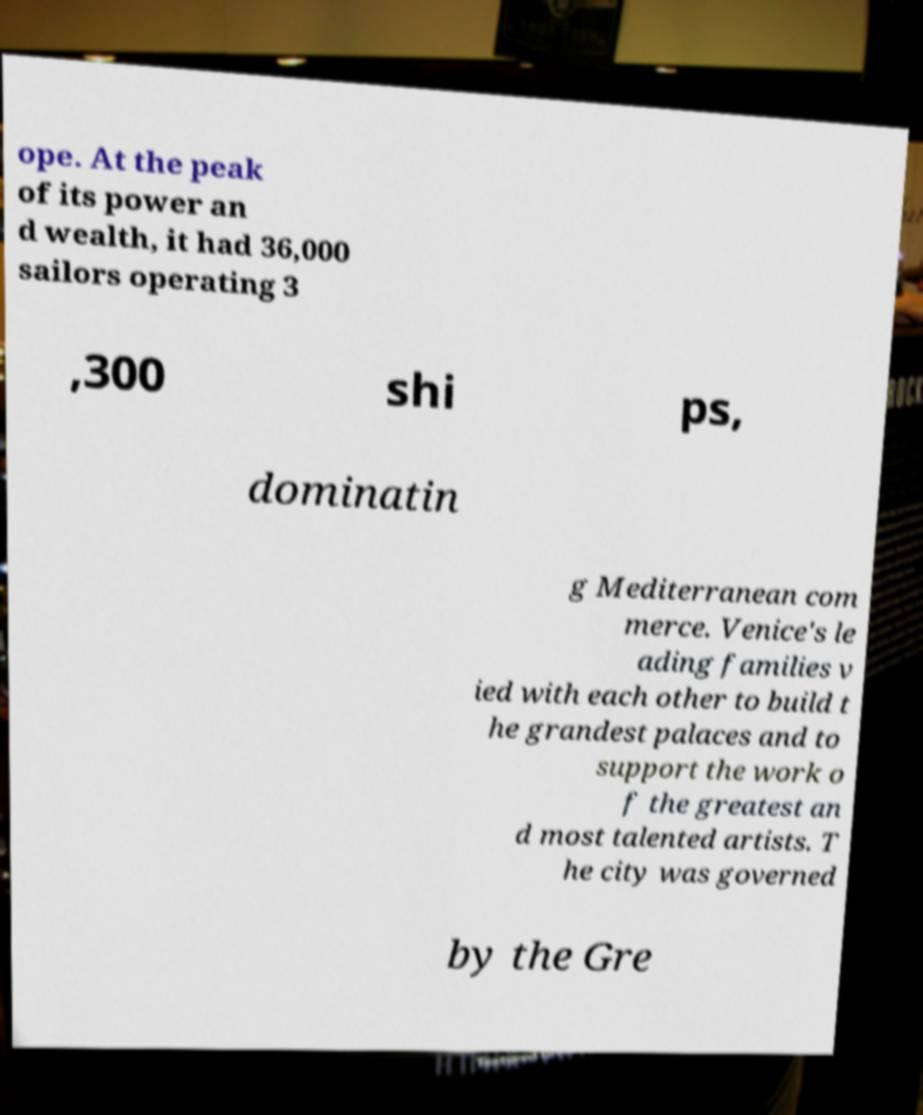I need the written content from this picture converted into text. Can you do that? ope. At the peak of its power an d wealth, it had 36,000 sailors operating 3 ,300 shi ps, dominatin g Mediterranean com merce. Venice's le ading families v ied with each other to build t he grandest palaces and to support the work o f the greatest an d most talented artists. T he city was governed by the Gre 